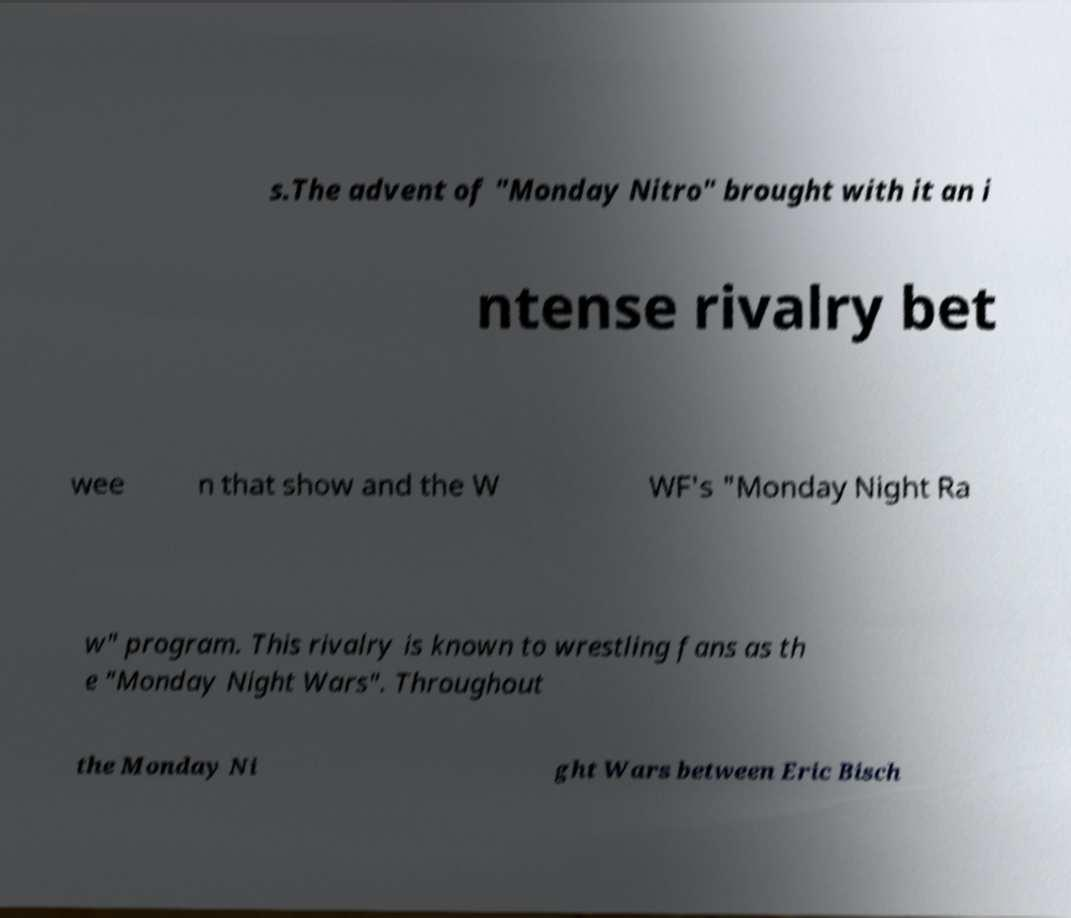Please identify and transcribe the text found in this image. s.The advent of "Monday Nitro" brought with it an i ntense rivalry bet wee n that show and the W WF's "Monday Night Ra w" program. This rivalry is known to wrestling fans as th e "Monday Night Wars". Throughout the Monday Ni ght Wars between Eric Bisch 